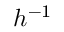Convert formula to latex. <formula><loc_0><loc_0><loc_500><loc_500>{ h ^ { - 1 } }</formula> 